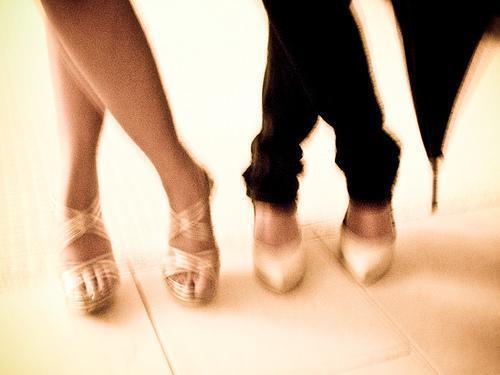How many people are visible?
Give a very brief answer. 2. 